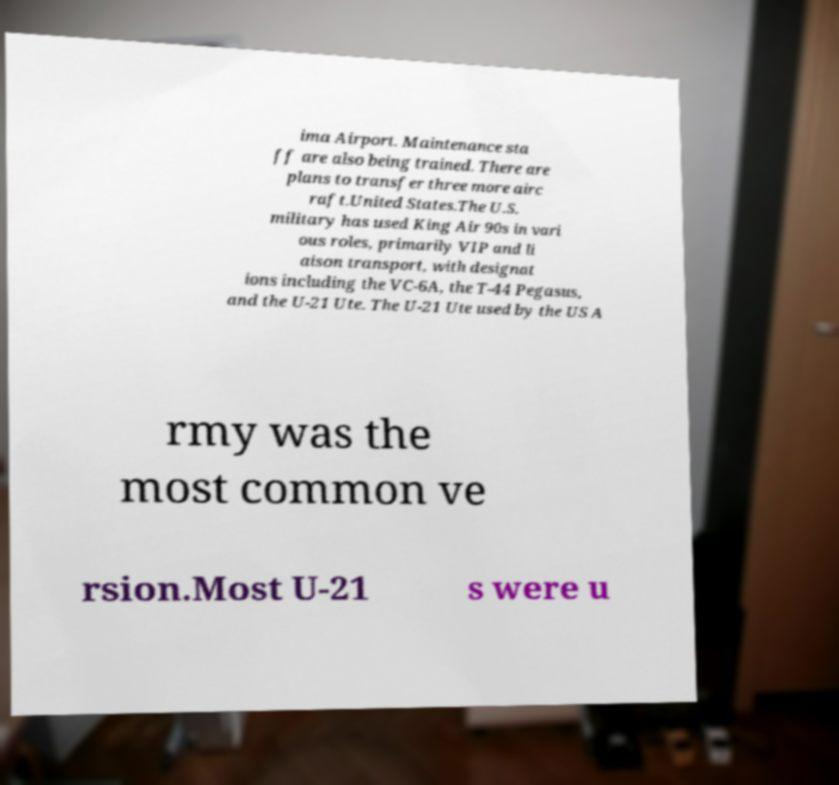Please identify and transcribe the text found in this image. ima Airport. Maintenance sta ff are also being trained. There are plans to transfer three more airc raft.United States.The U.S. military has used King Air 90s in vari ous roles, primarily VIP and li aison transport, with designat ions including the VC-6A, the T-44 Pegasus, and the U-21 Ute. The U-21 Ute used by the US A rmy was the most common ve rsion.Most U-21 s were u 